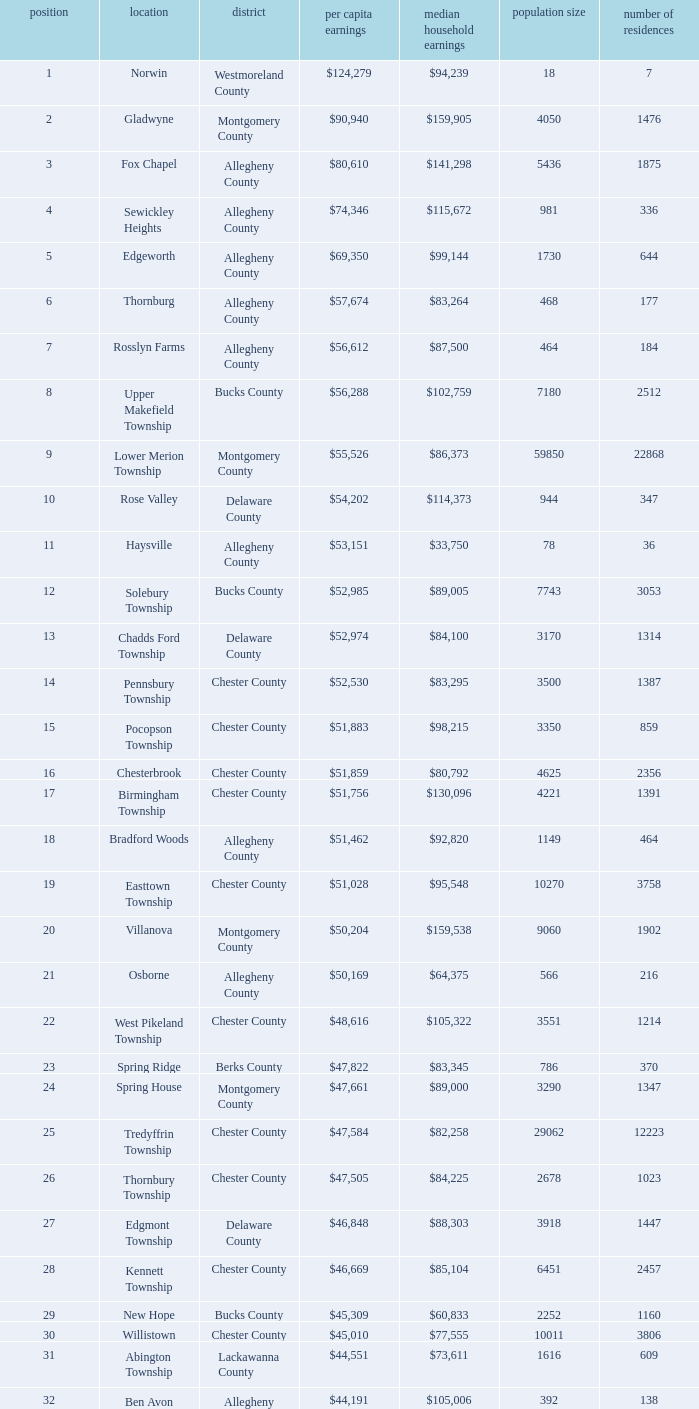What is the per capita income for Fayette County? $42,131. 